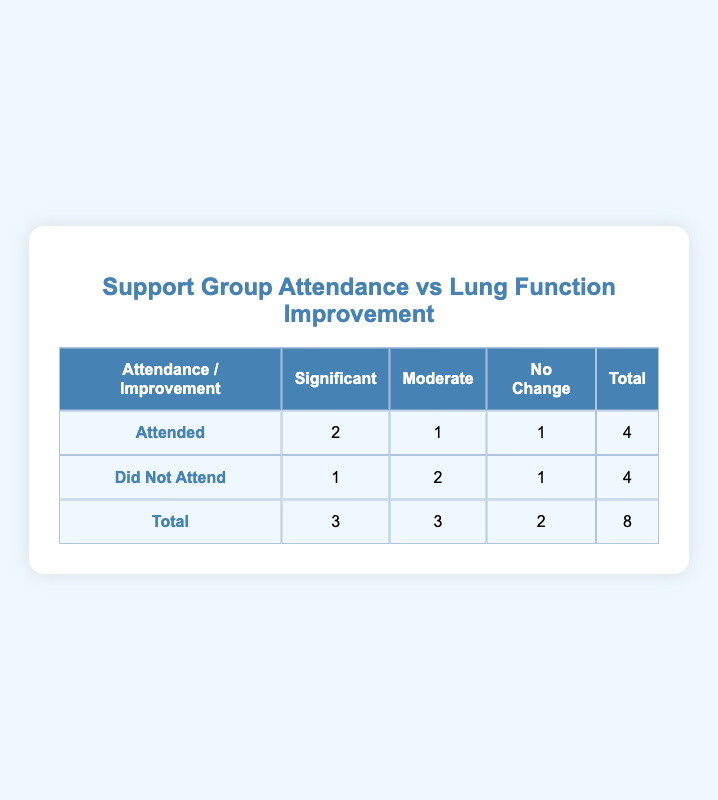What is the total number of participants who attended the support group meetings? From the table, under the "Attended" row, the total column shows 4 participants.
Answer: 4 How many participants did not experience any change in lung function but attended the meetings? In the "Attended" row, the "No Change" column indicates there was 1 participant who attended meetings but did not show any lung function improvement.
Answer: 1 What is the total number of participants who did not attend the support group meetings? The "Did Not Attend" row in the total column shows there are 4 participants who did not attend the meetings.
Answer: 4 How many participants experienced significant lung function improvement and did not attend the meetings? Looking at the "Did Not Attend" row, the "Significant" column shows there is 1 participant who had significant lung function improvement without attending the meetings.
Answer: 1 What is the average lung function improvement for participants who attended the meetings? There are 4 participants who attended, with improvements categorized as 2 significant, 1 moderate, and 1 no change. The average can be calculated as follows: (2*3 + 1*2 + 1*0) / 4 = (6 + 2 + 0) / 4 = 8 / 4 = 2, where significant is weighted 3, moderate is 2, and no change is 0.
Answer: 2 Which group had a higher count for "Moderate" improvement, attendees or non-attendees? Under the "Moderate" column, the attendees have 1, while the non-attendees show 2. Since 2 is greater than 1, the non-attendees had a higher count for moderate improvement.
Answer: Non-attendees Was there a participant who both attended the meetings and had no improvement? Yes, under the "Attended" row, the "No Change" column shows 1 participant who attended the meetings and had no improvement.
Answer: Yes How many total participants experienced significant improvement in lung function? Adding the totals for both "Attended" (2) and "Did Not Attend" (1) results in 3 participants who experienced significant improvement in lung function overall.
Answer: 3 What percentage of participants who attended the meetings saw significant improvement? The calculation is 2 participants with significant improvement out of 4 total attendees: (2/4) * 100 = 50%.
Answer: 50% 